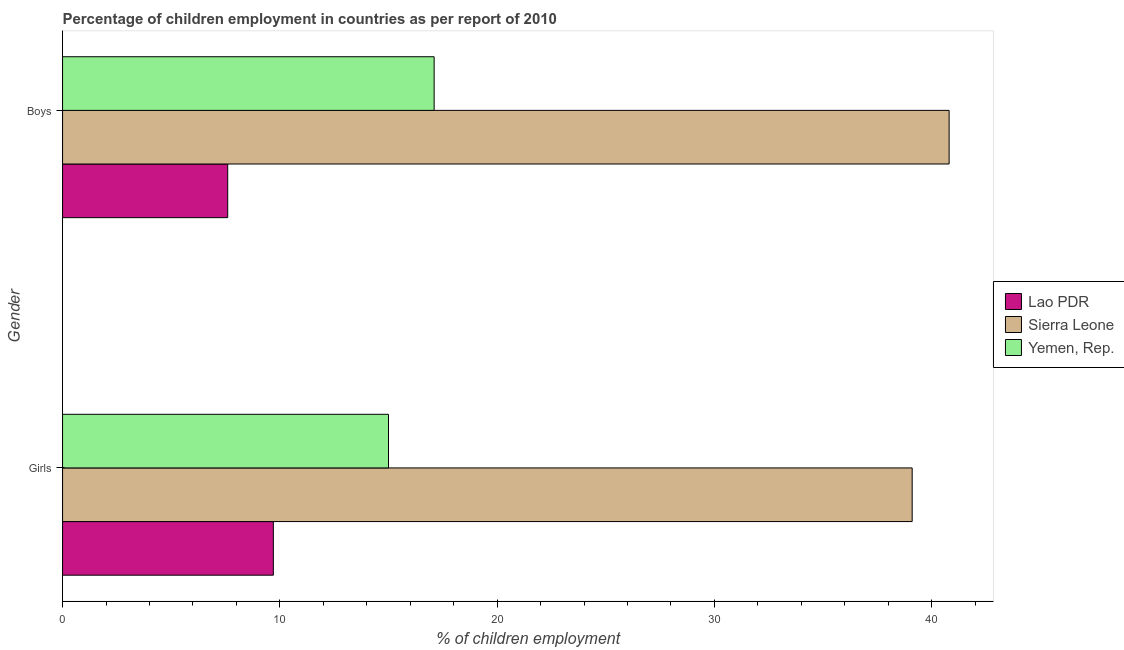How many different coloured bars are there?
Make the answer very short. 3. How many groups of bars are there?
Make the answer very short. 2. Are the number of bars per tick equal to the number of legend labels?
Your answer should be compact. Yes. What is the label of the 1st group of bars from the top?
Keep it short and to the point. Boys. What is the percentage of employed girls in Sierra Leone?
Provide a succinct answer. 39.1. Across all countries, what is the maximum percentage of employed girls?
Your response must be concise. 39.1. In which country was the percentage of employed boys maximum?
Your answer should be compact. Sierra Leone. In which country was the percentage of employed boys minimum?
Your answer should be very brief. Lao PDR. What is the total percentage of employed boys in the graph?
Your response must be concise. 65.5. What is the difference between the percentage of employed girls in Yemen, Rep. and that in Lao PDR?
Your answer should be compact. 5.3. What is the difference between the percentage of employed girls in Lao PDR and the percentage of employed boys in Sierra Leone?
Offer a terse response. -31.1. What is the average percentage of employed boys per country?
Offer a very short reply. 21.83. What is the difference between the percentage of employed boys and percentage of employed girls in Yemen, Rep.?
Offer a terse response. 2.1. What is the ratio of the percentage of employed boys in Sierra Leone to that in Yemen, Rep.?
Your answer should be very brief. 2.39. What does the 3rd bar from the top in Boys represents?
Make the answer very short. Lao PDR. What does the 2nd bar from the bottom in Girls represents?
Make the answer very short. Sierra Leone. How many bars are there?
Your response must be concise. 6. Are all the bars in the graph horizontal?
Your answer should be compact. Yes. Are the values on the major ticks of X-axis written in scientific E-notation?
Your answer should be very brief. No. Does the graph contain grids?
Provide a short and direct response. No. How are the legend labels stacked?
Your answer should be compact. Vertical. What is the title of the graph?
Offer a very short reply. Percentage of children employment in countries as per report of 2010. Does "Kuwait" appear as one of the legend labels in the graph?
Offer a terse response. No. What is the label or title of the X-axis?
Offer a terse response. % of children employment. What is the % of children employment of Lao PDR in Girls?
Keep it short and to the point. 9.7. What is the % of children employment of Sierra Leone in Girls?
Offer a terse response. 39.1. What is the % of children employment of Sierra Leone in Boys?
Your answer should be compact. 40.8. Across all Gender, what is the maximum % of children employment of Sierra Leone?
Your response must be concise. 40.8. Across all Gender, what is the maximum % of children employment of Yemen, Rep.?
Your answer should be very brief. 17.1. Across all Gender, what is the minimum % of children employment of Lao PDR?
Your response must be concise. 7.6. Across all Gender, what is the minimum % of children employment of Sierra Leone?
Provide a short and direct response. 39.1. Across all Gender, what is the minimum % of children employment of Yemen, Rep.?
Offer a very short reply. 15. What is the total % of children employment in Lao PDR in the graph?
Offer a very short reply. 17.3. What is the total % of children employment in Sierra Leone in the graph?
Keep it short and to the point. 79.9. What is the total % of children employment of Yemen, Rep. in the graph?
Your answer should be very brief. 32.1. What is the difference between the % of children employment of Yemen, Rep. in Girls and that in Boys?
Provide a succinct answer. -2.1. What is the difference between the % of children employment in Lao PDR in Girls and the % of children employment in Sierra Leone in Boys?
Your answer should be very brief. -31.1. What is the difference between the % of children employment of Sierra Leone in Girls and the % of children employment of Yemen, Rep. in Boys?
Provide a short and direct response. 22. What is the average % of children employment in Lao PDR per Gender?
Give a very brief answer. 8.65. What is the average % of children employment of Sierra Leone per Gender?
Provide a short and direct response. 39.95. What is the average % of children employment of Yemen, Rep. per Gender?
Your response must be concise. 16.05. What is the difference between the % of children employment in Lao PDR and % of children employment in Sierra Leone in Girls?
Give a very brief answer. -29.4. What is the difference between the % of children employment in Lao PDR and % of children employment in Yemen, Rep. in Girls?
Ensure brevity in your answer.  -5.3. What is the difference between the % of children employment of Sierra Leone and % of children employment of Yemen, Rep. in Girls?
Offer a terse response. 24.1. What is the difference between the % of children employment of Lao PDR and % of children employment of Sierra Leone in Boys?
Make the answer very short. -33.2. What is the difference between the % of children employment in Sierra Leone and % of children employment in Yemen, Rep. in Boys?
Offer a very short reply. 23.7. What is the ratio of the % of children employment of Lao PDR in Girls to that in Boys?
Keep it short and to the point. 1.28. What is the ratio of the % of children employment in Sierra Leone in Girls to that in Boys?
Your response must be concise. 0.96. What is the ratio of the % of children employment of Yemen, Rep. in Girls to that in Boys?
Offer a terse response. 0.88. What is the difference between the highest and the second highest % of children employment in Sierra Leone?
Keep it short and to the point. 1.7. What is the difference between the highest and the second highest % of children employment in Yemen, Rep.?
Make the answer very short. 2.1. What is the difference between the highest and the lowest % of children employment of Lao PDR?
Offer a very short reply. 2.1. What is the difference between the highest and the lowest % of children employment of Yemen, Rep.?
Your response must be concise. 2.1. 